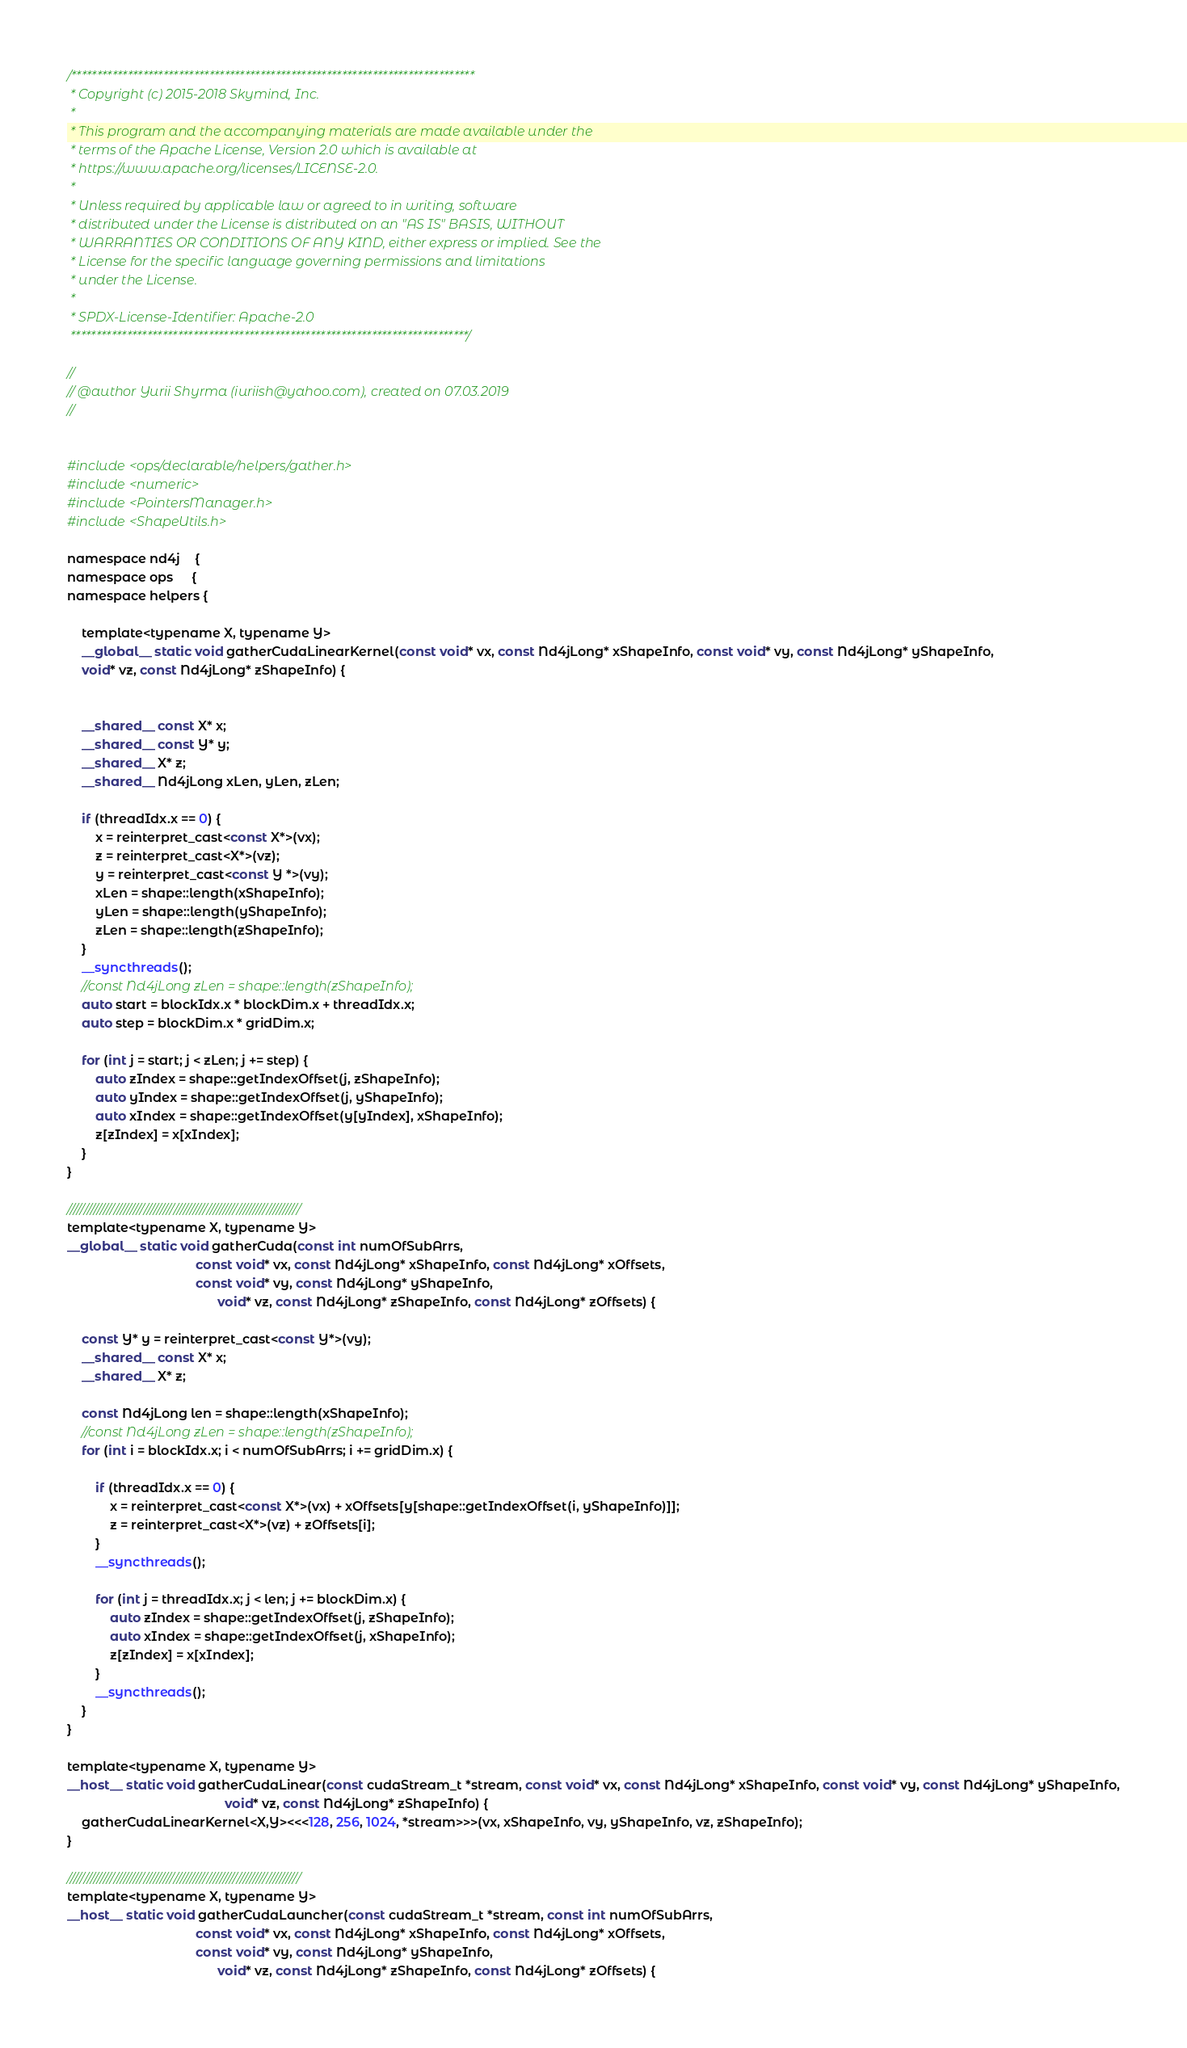Convert code to text. <code><loc_0><loc_0><loc_500><loc_500><_Cuda_>/*******************************************************************************
 * Copyright (c) 2015-2018 Skymind, Inc.
 *
 * This program and the accompanying materials are made available under the
 * terms of the Apache License, Version 2.0 which is available at
 * https://www.apache.org/licenses/LICENSE-2.0.
 *
 * Unless required by applicable law or agreed to in writing, software
 * distributed under the License is distributed on an "AS IS" BASIS, WITHOUT
 * WARRANTIES OR CONDITIONS OF ANY KIND, either express or implied. See the
 * License for the specific language governing permissions and limitations
 * under the License.
 *
 * SPDX-License-Identifier: Apache-2.0
 ******************************************************************************/

//
// @author Yurii Shyrma (iuriish@yahoo.com), created on 07.03.2019
//


#include <ops/declarable/helpers/gather.h>
#include <numeric>
#include <PointersManager.h>
#include <ShapeUtils.h>

namespace nd4j    {
namespace ops     {
namespace helpers {

    template<typename X, typename Y>
    __global__ static void gatherCudaLinearKernel(const void* vx, const Nd4jLong* xShapeInfo, const void* vy, const Nd4jLong* yShapeInfo,
    void* vz, const Nd4jLong* zShapeInfo) {


    __shared__ const X* x;
    __shared__ const Y* y;
    __shared__ X* z;
    __shared__ Nd4jLong xLen, yLen, zLen;

    if (threadIdx.x == 0) {
        x = reinterpret_cast<const X*>(vx);
        z = reinterpret_cast<X*>(vz);
        y = reinterpret_cast<const Y *>(vy);
        xLen = shape::length(xShapeInfo);
        yLen = shape::length(yShapeInfo);
        zLen = shape::length(zShapeInfo);
    }
    __syncthreads();
    //const Nd4jLong zLen = shape::length(zShapeInfo);
    auto start = blockIdx.x * blockDim.x + threadIdx.x;
    auto step = blockDim.x * gridDim.x;

    for (int j = start; j < zLen; j += step) {
        auto zIndex = shape::getIndexOffset(j, zShapeInfo);
        auto yIndex = shape::getIndexOffset(j, yShapeInfo);
        auto xIndex = shape::getIndexOffset(y[yIndex], xShapeInfo);
        z[zIndex] = x[xIndex];
    }
}

//////////////////////////////////////////////////////////////////////
template<typename X, typename Y>
__global__ static void gatherCuda(const int numOfSubArrs,
                                    const void* vx, const Nd4jLong* xShapeInfo, const Nd4jLong* xOffsets,
                                    const void* vy, const Nd4jLong* yShapeInfo,
                                          void* vz, const Nd4jLong* zShapeInfo, const Nd4jLong* zOffsets) {

    const Y* y = reinterpret_cast<const Y*>(vy);
    __shared__ const X* x;
    __shared__ X* z;

    const Nd4jLong len = shape::length(xShapeInfo);
    //const Nd4jLong zLen = shape::length(zShapeInfo);
    for (int i = blockIdx.x; i < numOfSubArrs; i += gridDim.x) {

        if (threadIdx.x == 0) {
            x = reinterpret_cast<const X*>(vx) + xOffsets[y[shape::getIndexOffset(i, yShapeInfo)]];
            z = reinterpret_cast<X*>(vz) + zOffsets[i];
        }
        __syncthreads();

        for (int j = threadIdx.x; j < len; j += blockDim.x) {
            auto zIndex = shape::getIndexOffset(j, zShapeInfo);
            auto xIndex = shape::getIndexOffset(j, xShapeInfo);
            z[zIndex] = x[xIndex];
        }
        __syncthreads();
    }
}

template<typename X, typename Y>
__host__ static void gatherCudaLinear(const cudaStream_t *stream, const void* vx, const Nd4jLong* xShapeInfo, const void* vy, const Nd4jLong* yShapeInfo,
                                            void* vz, const Nd4jLong* zShapeInfo) {
    gatherCudaLinearKernel<X,Y><<<128, 256, 1024, *stream>>>(vx, xShapeInfo, vy, yShapeInfo, vz, zShapeInfo);
}

//////////////////////////////////////////////////////////////////////
template<typename X, typename Y>
__host__ static void gatherCudaLauncher(const cudaStream_t *stream, const int numOfSubArrs,
                                    const void* vx, const Nd4jLong* xShapeInfo, const Nd4jLong* xOffsets,
                                    const void* vy, const Nd4jLong* yShapeInfo,
                                          void* vz, const Nd4jLong* zShapeInfo, const Nd4jLong* zOffsets) {</code> 